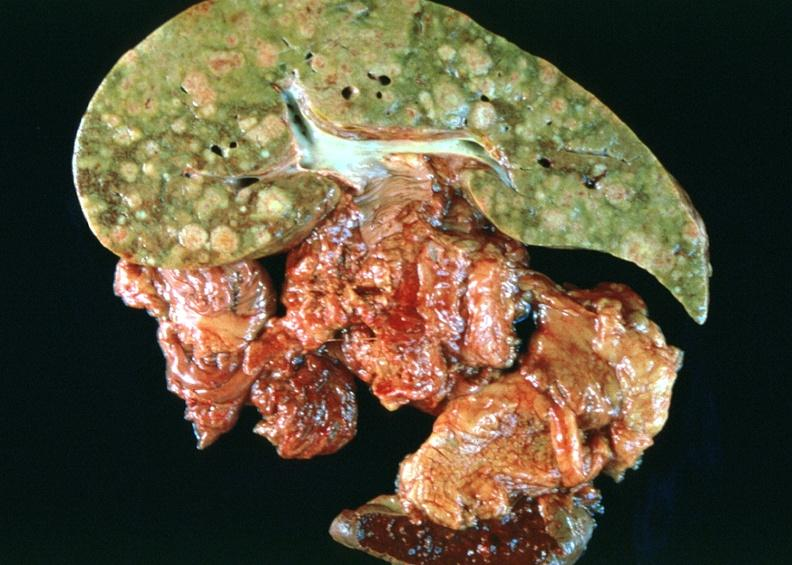s single metastatic appearing lesion present?
Answer the question using a single word or phrase. No 